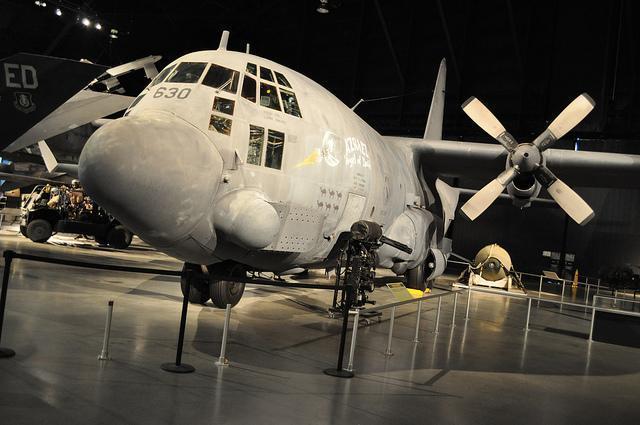How many windows are visible?
Give a very brief answer. 13. How many giraffes are there?
Give a very brief answer. 0. 